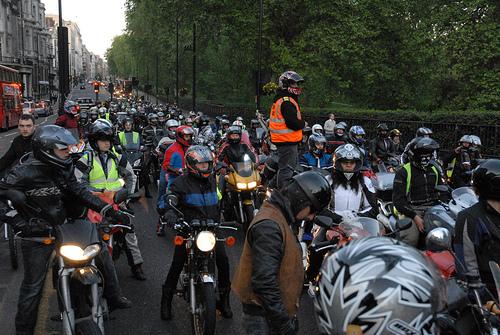Why is the man wearing a reflector jacket?
Give a very brief answer. Safety. What are they riding?
Answer briefly. Motorcycles. Is this a bikers' meeting?
Keep it brief. Yes. Is the biker at the back wearing a sleeveless shirt?
Be succinct. No. How many motorcycles are there?
Short answer required. 100. Is everyone wearing jackets?
Write a very short answer. Yes. What is the spherical silver object in the lower right corner?
Be succinct. Helmet. 